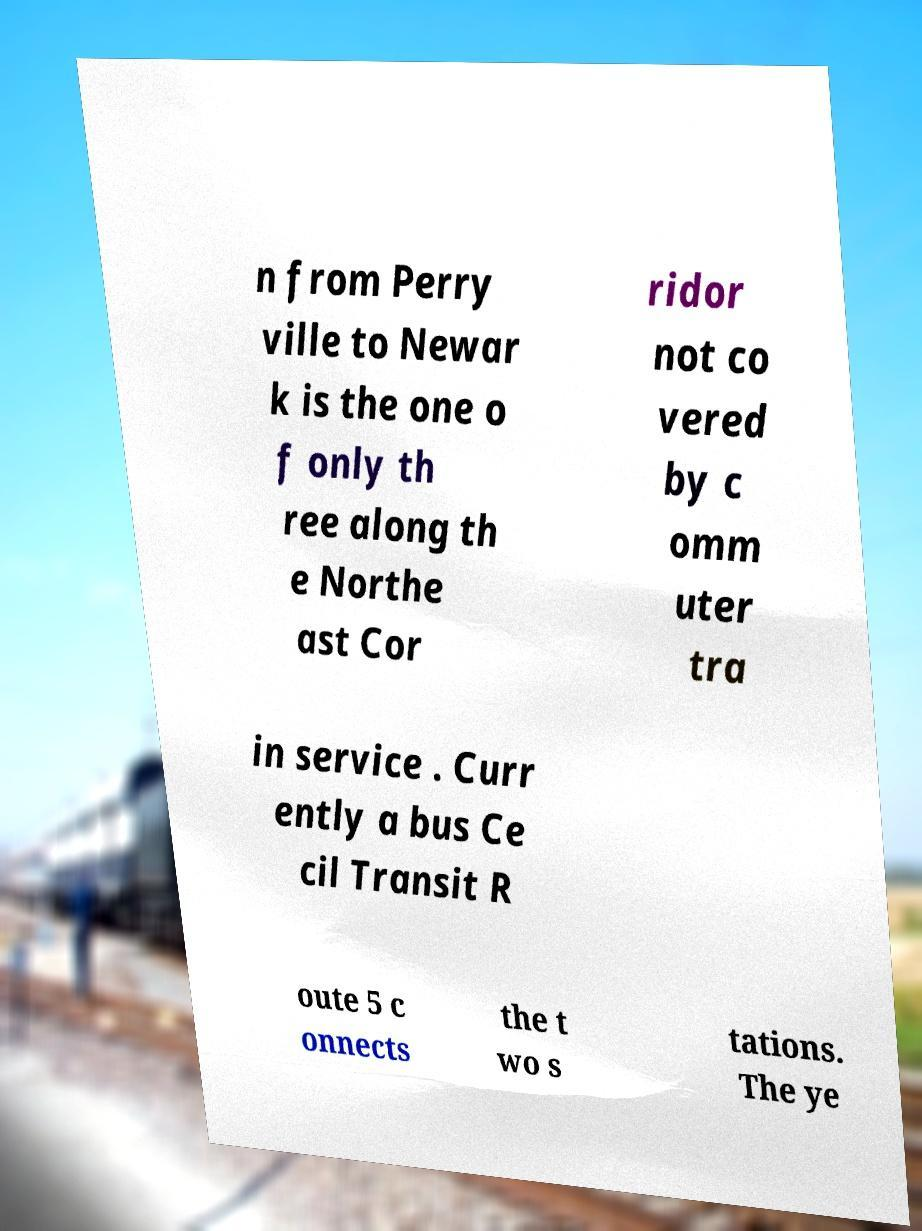For documentation purposes, I need the text within this image transcribed. Could you provide that? n from Perry ville to Newar k is the one o f only th ree along th e Northe ast Cor ridor not co vered by c omm uter tra in service . Curr ently a bus Ce cil Transit R oute 5 c onnects the t wo s tations. The ye 